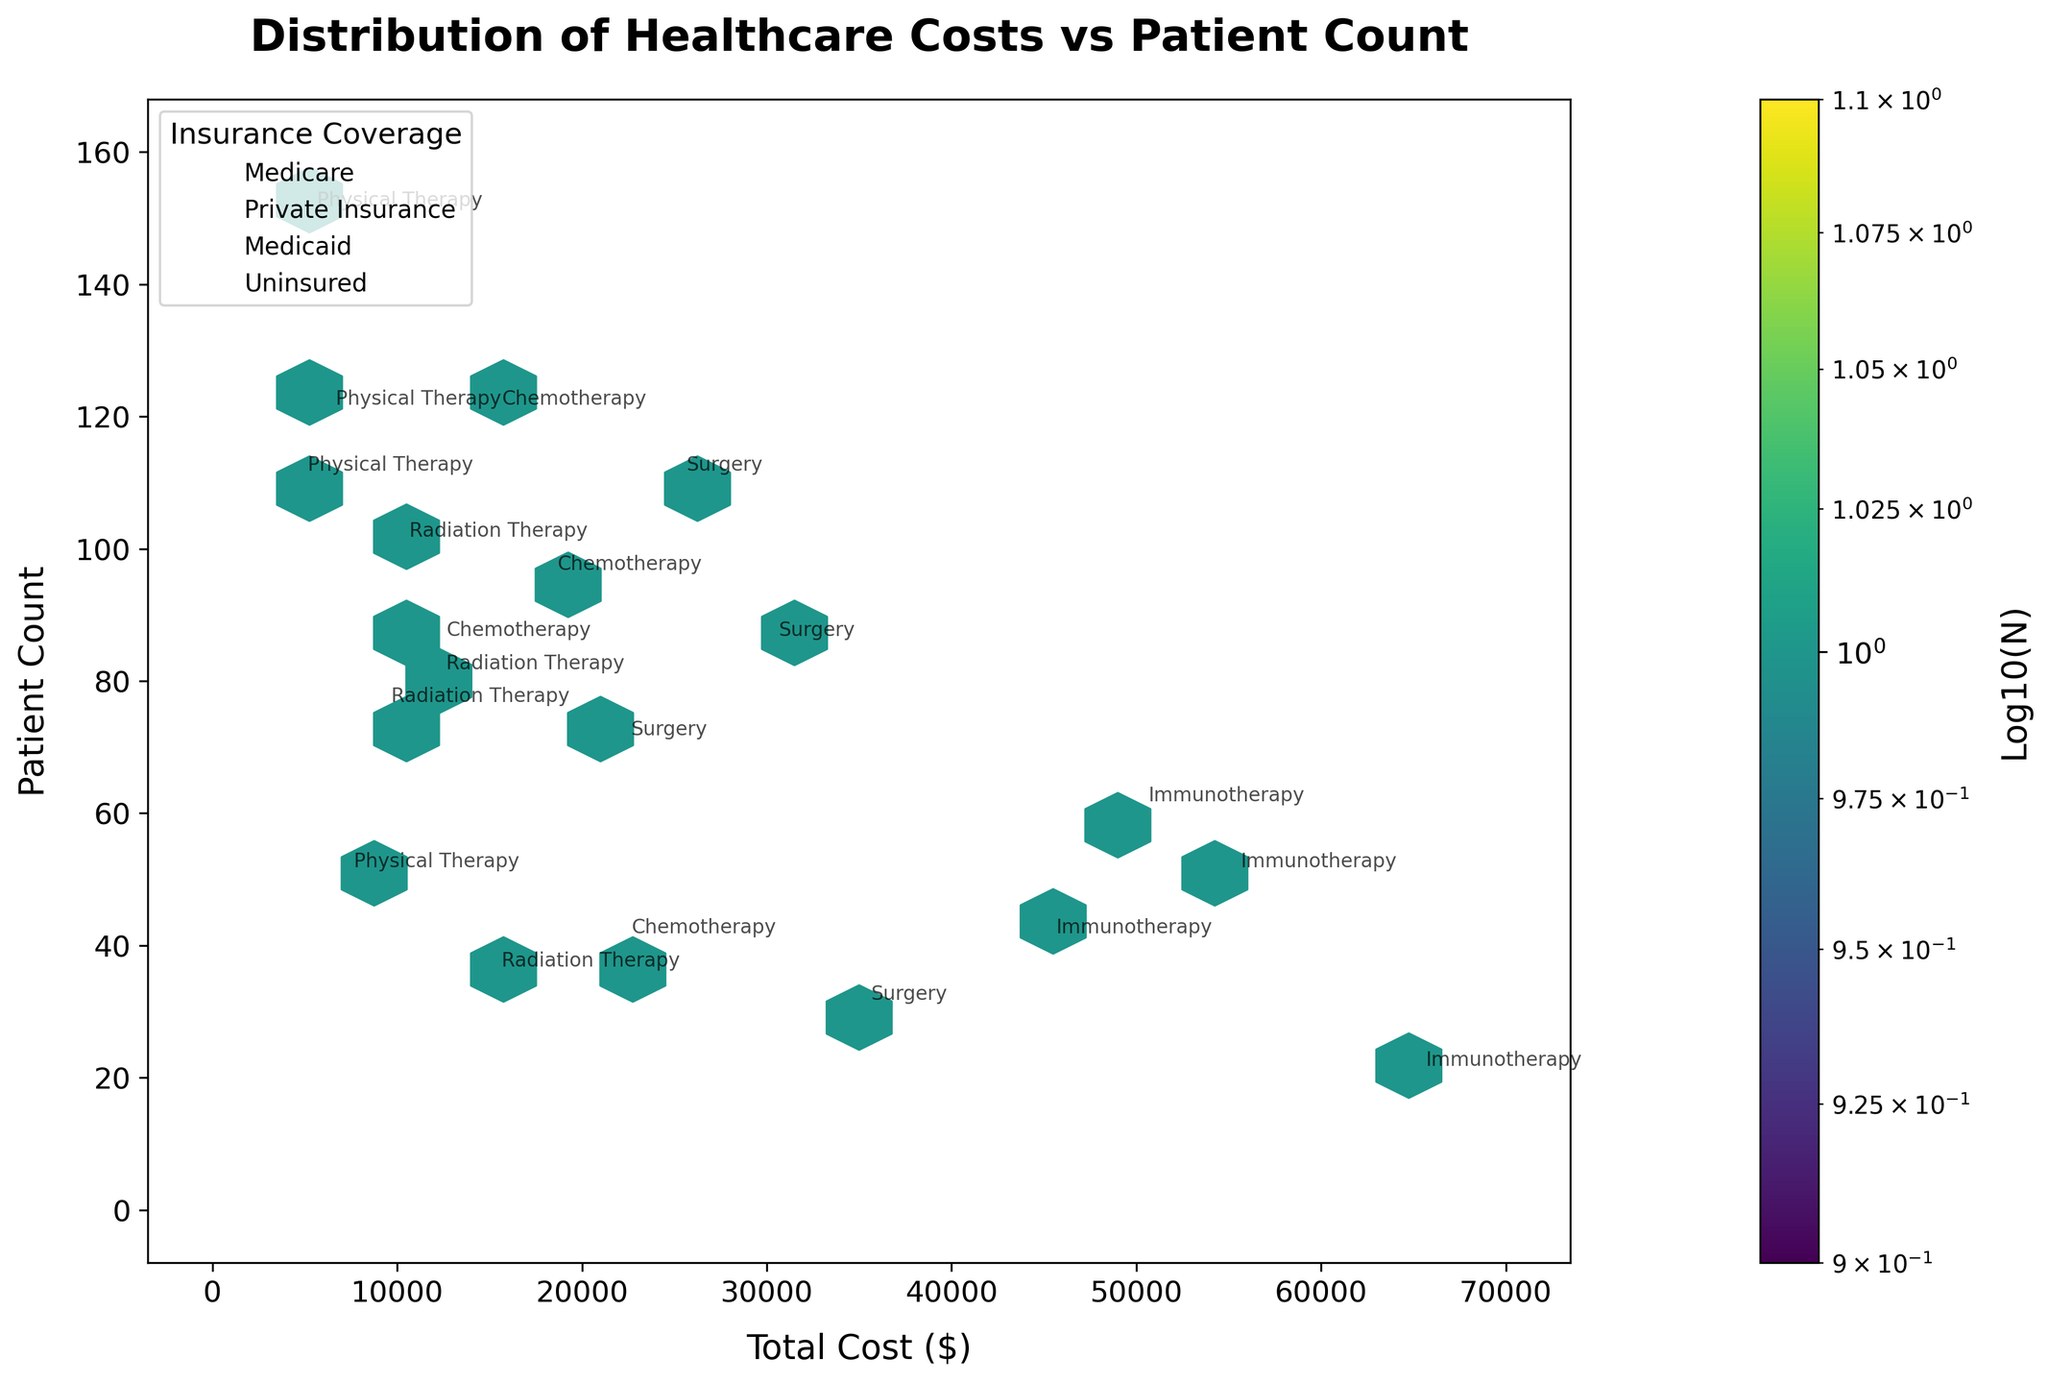What's the title of the figure? The title is typically located at the top of the figure, centered for visibility. The title in this plot reads "Distribution of Healthcare Costs vs Patient Count".
Answer: Distribution of Healthcare Costs vs Patient Count What do the x-axis and y-axis represent? Look at the labels on both axes. The x-axis represents "Total Cost ($)" and the y-axis represents "Patient Count".
Answer: Total Cost ($) and Patient Count Which treatment type is annotated at around $50,000 total cost and a patient count of 60? Analyze the annotations around these coordinates. The treatment type with $50,000 cost and 60 patients is Immunotherapy.
Answer: Immunotherapy How are the insurance coverages represented in this plot? The legend indicates the different insurance coverages. Each unique insurance type is represented by different scatter points along with annotations on the plot for reference.
Answer: Different scatter points and annotations What is the color scale representing on the hexbin plot? The color scale, referenced by the colorbar, represents the logarithm (base 10) of the number of points (N) in each hexagonal bin.
Answer: Logarithm (base 10) of the number of points What's the total cost and patient count for the treatment type with the lowest cost in the dataset? Identify the lowest cost from the x-axis, which corresponds to Physical Therapy at $4,500 with Medicaid insurance and a patient count of 110.
Answer: $4,500, 110 patients Which treatment type has the highest total cost, and what is its patient count? Look for the annotation at the highest cost on the x-axis. The highest cost is $65,000 for Immunotherapy with 20 patients.
Answer: Immunotherapy, $65,000, 20 patients Among the treatment types, which one generally has the highest patient counts? Check the upper values on the y-axis and cross-reference with annotations. Physical Therapy has patient counts around 150.
Answer: Physical Therapy Compare the patient count for uninsured patients between Chemotherapy and Surgery. Which has more patients? Refer to the annotations for uninsured patients in both treatment types. Chemotherapy has 40, Surgery has 30. Chemotherapy has more.
Answer: Chemotherapy What trend do you observe between the total cost and patient count for the different types of treatments? Analyze how patient count changes with varying total costs. Generally, as total cost increases, the patient count tends to decrease.
Answer: Higher costs generally correspond to lower patient counts 